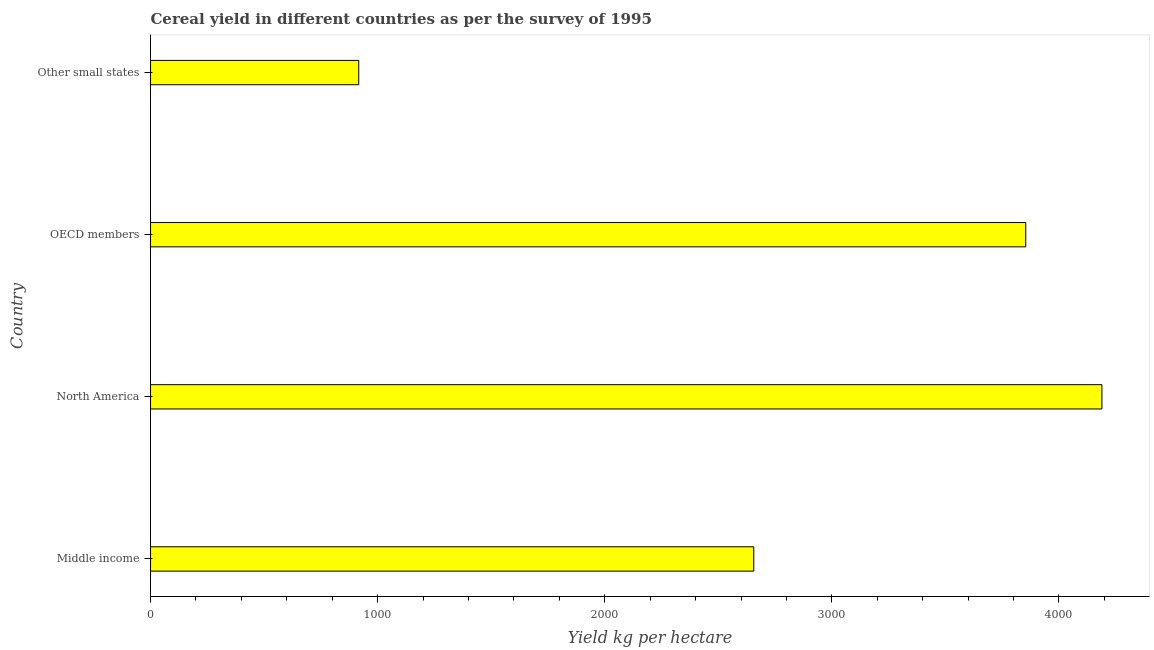Does the graph contain grids?
Provide a short and direct response. No. What is the title of the graph?
Make the answer very short. Cereal yield in different countries as per the survey of 1995. What is the label or title of the X-axis?
Provide a succinct answer. Yield kg per hectare. What is the label or title of the Y-axis?
Offer a terse response. Country. What is the cereal yield in North America?
Ensure brevity in your answer.  4189.3. Across all countries, what is the maximum cereal yield?
Provide a short and direct response. 4189.3. Across all countries, what is the minimum cereal yield?
Your answer should be very brief. 916.82. In which country was the cereal yield minimum?
Provide a succinct answer. Other small states. What is the sum of the cereal yield?
Your answer should be compact. 1.16e+04. What is the difference between the cereal yield in Middle income and Other small states?
Your answer should be compact. 1739.5. What is the average cereal yield per country?
Keep it short and to the point. 2904.09. What is the median cereal yield?
Offer a very short reply. 3255.12. What is the ratio of the cereal yield in Middle income to that in OECD members?
Offer a terse response. 0.69. What is the difference between the highest and the second highest cereal yield?
Your answer should be very brief. 335.38. Is the sum of the cereal yield in Middle income and OECD members greater than the maximum cereal yield across all countries?
Your answer should be very brief. Yes. What is the difference between the highest and the lowest cereal yield?
Provide a succinct answer. 3272.49. In how many countries, is the cereal yield greater than the average cereal yield taken over all countries?
Give a very brief answer. 2. How many bars are there?
Ensure brevity in your answer.  4. How many countries are there in the graph?
Provide a short and direct response. 4. What is the difference between two consecutive major ticks on the X-axis?
Provide a short and direct response. 1000. What is the Yield kg per hectare in Middle income?
Make the answer very short. 2656.31. What is the Yield kg per hectare in North America?
Offer a terse response. 4189.3. What is the Yield kg per hectare of OECD members?
Make the answer very short. 3853.93. What is the Yield kg per hectare in Other small states?
Provide a short and direct response. 916.82. What is the difference between the Yield kg per hectare in Middle income and North America?
Ensure brevity in your answer.  -1532.99. What is the difference between the Yield kg per hectare in Middle income and OECD members?
Ensure brevity in your answer.  -1197.62. What is the difference between the Yield kg per hectare in Middle income and Other small states?
Offer a very short reply. 1739.5. What is the difference between the Yield kg per hectare in North America and OECD members?
Offer a very short reply. 335.38. What is the difference between the Yield kg per hectare in North America and Other small states?
Your response must be concise. 3272.49. What is the difference between the Yield kg per hectare in OECD members and Other small states?
Provide a short and direct response. 2937.11. What is the ratio of the Yield kg per hectare in Middle income to that in North America?
Your response must be concise. 0.63. What is the ratio of the Yield kg per hectare in Middle income to that in OECD members?
Give a very brief answer. 0.69. What is the ratio of the Yield kg per hectare in Middle income to that in Other small states?
Provide a succinct answer. 2.9. What is the ratio of the Yield kg per hectare in North America to that in OECD members?
Your answer should be compact. 1.09. What is the ratio of the Yield kg per hectare in North America to that in Other small states?
Offer a very short reply. 4.57. What is the ratio of the Yield kg per hectare in OECD members to that in Other small states?
Your response must be concise. 4.2. 